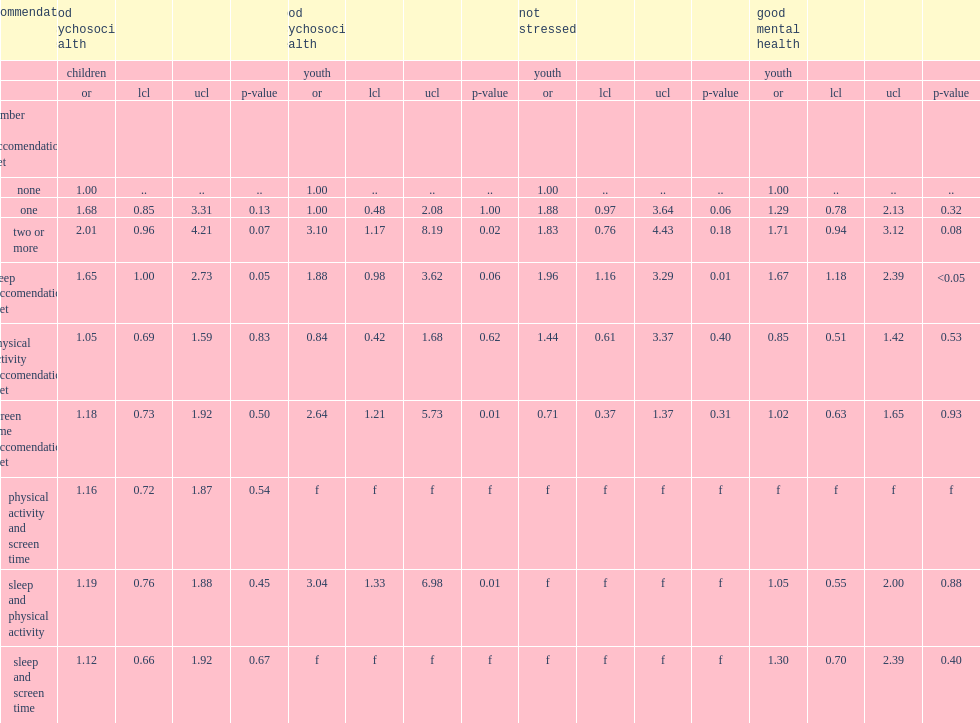Which was associated with substantially higher odds of possessing a normal sdq score among youth, those meeting two or more of the 24-hour guidelines recommendations or those not meeting any of the guidelines? Two or more. How many times higher odds of good psychosocial health did youth who met the screen time recommendations have compared to those who did not meet the screen time recommendations? 2.64. Who were found to have a higher likelihood of not being stressed, youth who met the sleep recommendations or those who did not? Sleep reccomendation met. Which kind of youth had higher odds reporting very good to excellent mental health, meeting the sleep recommendations or not? Sleep reccomendation met. 